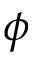Convert formula to latex. <formula><loc_0><loc_0><loc_500><loc_500>\phi</formula> 